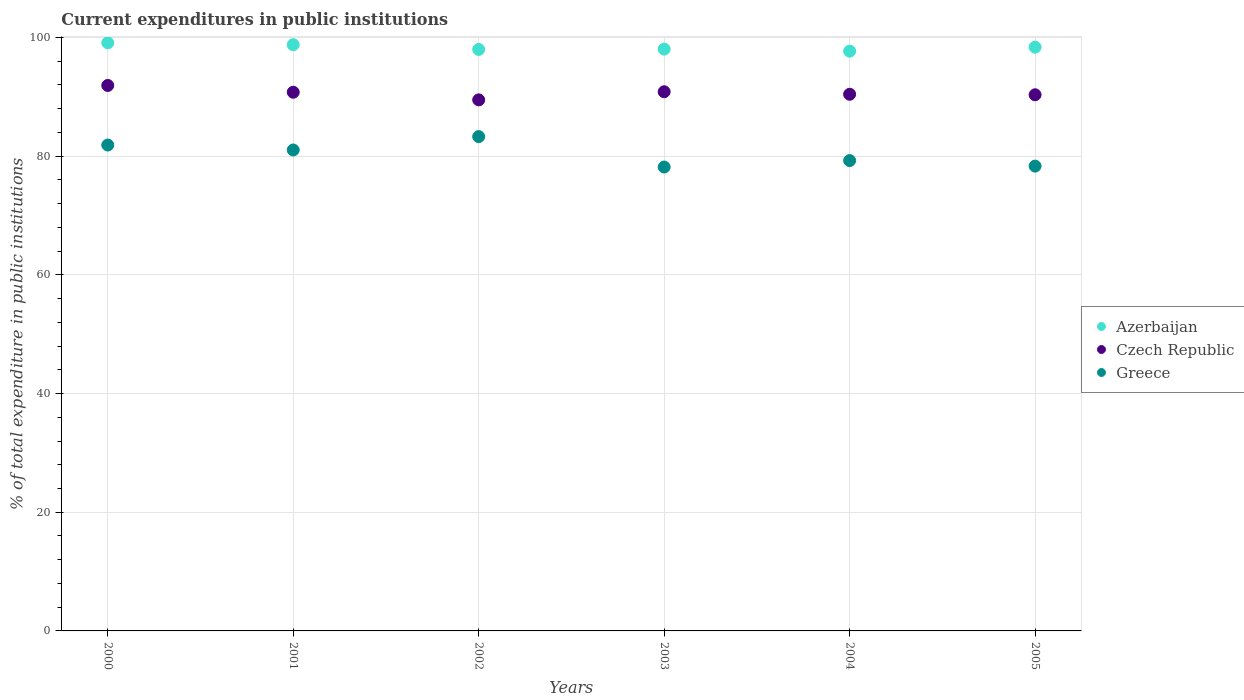What is the current expenditures in public institutions in Greece in 2004?
Your response must be concise. 79.25. Across all years, what is the maximum current expenditures in public institutions in Azerbaijan?
Give a very brief answer. 99.1. Across all years, what is the minimum current expenditures in public institutions in Czech Republic?
Ensure brevity in your answer.  89.48. In which year was the current expenditures in public institutions in Greece minimum?
Offer a very short reply. 2003. What is the total current expenditures in public institutions in Czech Republic in the graph?
Offer a very short reply. 543.78. What is the difference between the current expenditures in public institutions in Azerbaijan in 2003 and that in 2004?
Your answer should be very brief. 0.34. What is the difference between the current expenditures in public institutions in Azerbaijan in 2003 and the current expenditures in public institutions in Czech Republic in 2000?
Ensure brevity in your answer.  6.12. What is the average current expenditures in public institutions in Greece per year?
Offer a very short reply. 80.32. In the year 2000, what is the difference between the current expenditures in public institutions in Azerbaijan and current expenditures in public institutions in Greece?
Make the answer very short. 17.23. In how many years, is the current expenditures in public institutions in Azerbaijan greater than 24 %?
Your response must be concise. 6. What is the ratio of the current expenditures in public institutions in Greece in 2000 to that in 2005?
Your answer should be compact. 1.05. Is the current expenditures in public institutions in Azerbaijan in 2001 less than that in 2005?
Offer a terse response. No. Is the difference between the current expenditures in public institutions in Azerbaijan in 2000 and 2005 greater than the difference between the current expenditures in public institutions in Greece in 2000 and 2005?
Your answer should be compact. No. What is the difference between the highest and the second highest current expenditures in public institutions in Greece?
Give a very brief answer. 1.42. What is the difference between the highest and the lowest current expenditures in public institutions in Greece?
Provide a succinct answer. 5.13. Is the sum of the current expenditures in public institutions in Greece in 2002 and 2004 greater than the maximum current expenditures in public institutions in Czech Republic across all years?
Your answer should be compact. Yes. Is it the case that in every year, the sum of the current expenditures in public institutions in Azerbaijan and current expenditures in public institutions in Czech Republic  is greater than the current expenditures in public institutions in Greece?
Keep it short and to the point. Yes. Is the current expenditures in public institutions in Greece strictly less than the current expenditures in public institutions in Czech Republic over the years?
Give a very brief answer. Yes. How many dotlines are there?
Make the answer very short. 3. What is the difference between two consecutive major ticks on the Y-axis?
Keep it short and to the point. 20. Does the graph contain any zero values?
Keep it short and to the point. No. Does the graph contain grids?
Your response must be concise. Yes. How are the legend labels stacked?
Your answer should be compact. Vertical. What is the title of the graph?
Offer a very short reply. Current expenditures in public institutions. What is the label or title of the X-axis?
Provide a succinct answer. Years. What is the label or title of the Y-axis?
Your answer should be compact. % of total expenditure in public institutions. What is the % of total expenditure in public institutions in Azerbaijan in 2000?
Offer a very short reply. 99.1. What is the % of total expenditure in public institutions in Czech Republic in 2000?
Offer a terse response. 91.91. What is the % of total expenditure in public institutions in Greece in 2000?
Your answer should be very brief. 81.87. What is the % of total expenditure in public institutions of Azerbaijan in 2001?
Provide a short and direct response. 98.78. What is the % of total expenditure in public institutions of Czech Republic in 2001?
Your answer should be compact. 90.77. What is the % of total expenditure in public institutions of Greece in 2001?
Ensure brevity in your answer.  81.04. What is the % of total expenditure in public institutions in Azerbaijan in 2002?
Make the answer very short. 97.98. What is the % of total expenditure in public institutions of Czech Republic in 2002?
Ensure brevity in your answer.  89.48. What is the % of total expenditure in public institutions of Greece in 2002?
Make the answer very short. 83.29. What is the % of total expenditure in public institutions of Azerbaijan in 2003?
Your answer should be very brief. 98.03. What is the % of total expenditure in public institutions of Czech Republic in 2003?
Give a very brief answer. 90.85. What is the % of total expenditure in public institutions in Greece in 2003?
Make the answer very short. 78.16. What is the % of total expenditure in public institutions of Azerbaijan in 2004?
Ensure brevity in your answer.  97.7. What is the % of total expenditure in public institutions of Czech Republic in 2004?
Your answer should be compact. 90.43. What is the % of total expenditure in public institutions in Greece in 2004?
Offer a terse response. 79.25. What is the % of total expenditure in public institutions of Azerbaijan in 2005?
Give a very brief answer. 98.36. What is the % of total expenditure in public institutions in Czech Republic in 2005?
Your answer should be very brief. 90.34. What is the % of total expenditure in public institutions in Greece in 2005?
Provide a short and direct response. 78.32. Across all years, what is the maximum % of total expenditure in public institutions in Azerbaijan?
Your response must be concise. 99.1. Across all years, what is the maximum % of total expenditure in public institutions of Czech Republic?
Provide a succinct answer. 91.91. Across all years, what is the maximum % of total expenditure in public institutions in Greece?
Provide a succinct answer. 83.29. Across all years, what is the minimum % of total expenditure in public institutions in Azerbaijan?
Provide a short and direct response. 97.7. Across all years, what is the minimum % of total expenditure in public institutions of Czech Republic?
Give a very brief answer. 89.48. Across all years, what is the minimum % of total expenditure in public institutions of Greece?
Offer a very short reply. 78.16. What is the total % of total expenditure in public institutions in Azerbaijan in the graph?
Offer a terse response. 589.95. What is the total % of total expenditure in public institutions of Czech Republic in the graph?
Your response must be concise. 543.78. What is the total % of total expenditure in public institutions in Greece in the graph?
Make the answer very short. 481.94. What is the difference between the % of total expenditure in public institutions of Azerbaijan in 2000 and that in 2001?
Offer a terse response. 0.32. What is the difference between the % of total expenditure in public institutions of Czech Republic in 2000 and that in 2001?
Make the answer very short. 1.14. What is the difference between the % of total expenditure in public institutions of Greece in 2000 and that in 2001?
Your answer should be compact. 0.83. What is the difference between the % of total expenditure in public institutions of Azerbaijan in 2000 and that in 2002?
Make the answer very short. 1.12. What is the difference between the % of total expenditure in public institutions in Czech Republic in 2000 and that in 2002?
Your answer should be very brief. 2.43. What is the difference between the % of total expenditure in public institutions of Greece in 2000 and that in 2002?
Keep it short and to the point. -1.42. What is the difference between the % of total expenditure in public institutions in Azerbaijan in 2000 and that in 2003?
Make the answer very short. 1.07. What is the difference between the % of total expenditure in public institutions in Czech Republic in 2000 and that in 2003?
Your answer should be compact. 1.06. What is the difference between the % of total expenditure in public institutions in Greece in 2000 and that in 2003?
Provide a succinct answer. 3.71. What is the difference between the % of total expenditure in public institutions of Azerbaijan in 2000 and that in 2004?
Give a very brief answer. 1.41. What is the difference between the % of total expenditure in public institutions of Czech Republic in 2000 and that in 2004?
Keep it short and to the point. 1.49. What is the difference between the % of total expenditure in public institutions of Greece in 2000 and that in 2004?
Make the answer very short. 2.62. What is the difference between the % of total expenditure in public institutions of Azerbaijan in 2000 and that in 2005?
Provide a short and direct response. 0.74. What is the difference between the % of total expenditure in public institutions of Czech Republic in 2000 and that in 2005?
Your answer should be compact. 1.57. What is the difference between the % of total expenditure in public institutions in Greece in 2000 and that in 2005?
Ensure brevity in your answer.  3.55. What is the difference between the % of total expenditure in public institutions in Azerbaijan in 2001 and that in 2002?
Ensure brevity in your answer.  0.8. What is the difference between the % of total expenditure in public institutions of Czech Republic in 2001 and that in 2002?
Your answer should be very brief. 1.29. What is the difference between the % of total expenditure in public institutions of Greece in 2001 and that in 2002?
Provide a short and direct response. -2.25. What is the difference between the % of total expenditure in public institutions of Azerbaijan in 2001 and that in 2003?
Provide a short and direct response. 0.74. What is the difference between the % of total expenditure in public institutions in Czech Republic in 2001 and that in 2003?
Ensure brevity in your answer.  -0.08. What is the difference between the % of total expenditure in public institutions in Greece in 2001 and that in 2003?
Make the answer very short. 2.88. What is the difference between the % of total expenditure in public institutions of Azerbaijan in 2001 and that in 2004?
Provide a succinct answer. 1.08. What is the difference between the % of total expenditure in public institutions of Czech Republic in 2001 and that in 2004?
Your response must be concise. 0.34. What is the difference between the % of total expenditure in public institutions of Greece in 2001 and that in 2004?
Your answer should be very brief. 1.79. What is the difference between the % of total expenditure in public institutions of Azerbaijan in 2001 and that in 2005?
Provide a short and direct response. 0.42. What is the difference between the % of total expenditure in public institutions of Czech Republic in 2001 and that in 2005?
Give a very brief answer. 0.43. What is the difference between the % of total expenditure in public institutions in Greece in 2001 and that in 2005?
Provide a succinct answer. 2.72. What is the difference between the % of total expenditure in public institutions in Azerbaijan in 2002 and that in 2003?
Provide a short and direct response. -0.05. What is the difference between the % of total expenditure in public institutions of Czech Republic in 2002 and that in 2003?
Give a very brief answer. -1.37. What is the difference between the % of total expenditure in public institutions of Greece in 2002 and that in 2003?
Give a very brief answer. 5.13. What is the difference between the % of total expenditure in public institutions of Azerbaijan in 2002 and that in 2004?
Give a very brief answer. 0.29. What is the difference between the % of total expenditure in public institutions of Czech Republic in 2002 and that in 2004?
Offer a very short reply. -0.94. What is the difference between the % of total expenditure in public institutions of Greece in 2002 and that in 2004?
Offer a very short reply. 4.04. What is the difference between the % of total expenditure in public institutions of Azerbaijan in 2002 and that in 2005?
Ensure brevity in your answer.  -0.38. What is the difference between the % of total expenditure in public institutions in Czech Republic in 2002 and that in 2005?
Your answer should be very brief. -0.86. What is the difference between the % of total expenditure in public institutions of Greece in 2002 and that in 2005?
Offer a very short reply. 4.97. What is the difference between the % of total expenditure in public institutions in Azerbaijan in 2003 and that in 2004?
Your response must be concise. 0.34. What is the difference between the % of total expenditure in public institutions in Czech Republic in 2003 and that in 2004?
Your answer should be compact. 0.42. What is the difference between the % of total expenditure in public institutions of Greece in 2003 and that in 2004?
Ensure brevity in your answer.  -1.09. What is the difference between the % of total expenditure in public institutions of Azerbaijan in 2003 and that in 2005?
Keep it short and to the point. -0.33. What is the difference between the % of total expenditure in public institutions in Czech Republic in 2003 and that in 2005?
Make the answer very short. 0.51. What is the difference between the % of total expenditure in public institutions of Greece in 2003 and that in 2005?
Ensure brevity in your answer.  -0.16. What is the difference between the % of total expenditure in public institutions in Azerbaijan in 2004 and that in 2005?
Make the answer very short. -0.66. What is the difference between the % of total expenditure in public institutions of Czech Republic in 2004 and that in 2005?
Keep it short and to the point. 0.09. What is the difference between the % of total expenditure in public institutions in Greece in 2004 and that in 2005?
Give a very brief answer. 0.93. What is the difference between the % of total expenditure in public institutions in Azerbaijan in 2000 and the % of total expenditure in public institutions in Czech Republic in 2001?
Provide a short and direct response. 8.33. What is the difference between the % of total expenditure in public institutions of Azerbaijan in 2000 and the % of total expenditure in public institutions of Greece in 2001?
Make the answer very short. 18.06. What is the difference between the % of total expenditure in public institutions in Czech Republic in 2000 and the % of total expenditure in public institutions in Greece in 2001?
Keep it short and to the point. 10.87. What is the difference between the % of total expenditure in public institutions in Azerbaijan in 2000 and the % of total expenditure in public institutions in Czech Republic in 2002?
Give a very brief answer. 9.62. What is the difference between the % of total expenditure in public institutions in Azerbaijan in 2000 and the % of total expenditure in public institutions in Greece in 2002?
Give a very brief answer. 15.81. What is the difference between the % of total expenditure in public institutions in Czech Republic in 2000 and the % of total expenditure in public institutions in Greece in 2002?
Your response must be concise. 8.62. What is the difference between the % of total expenditure in public institutions of Azerbaijan in 2000 and the % of total expenditure in public institutions of Czech Republic in 2003?
Make the answer very short. 8.25. What is the difference between the % of total expenditure in public institutions of Azerbaijan in 2000 and the % of total expenditure in public institutions of Greece in 2003?
Ensure brevity in your answer.  20.94. What is the difference between the % of total expenditure in public institutions of Czech Republic in 2000 and the % of total expenditure in public institutions of Greece in 2003?
Ensure brevity in your answer.  13.75. What is the difference between the % of total expenditure in public institutions in Azerbaijan in 2000 and the % of total expenditure in public institutions in Czech Republic in 2004?
Ensure brevity in your answer.  8.67. What is the difference between the % of total expenditure in public institutions of Azerbaijan in 2000 and the % of total expenditure in public institutions of Greece in 2004?
Offer a terse response. 19.85. What is the difference between the % of total expenditure in public institutions in Czech Republic in 2000 and the % of total expenditure in public institutions in Greece in 2004?
Provide a short and direct response. 12.66. What is the difference between the % of total expenditure in public institutions of Azerbaijan in 2000 and the % of total expenditure in public institutions of Czech Republic in 2005?
Give a very brief answer. 8.76. What is the difference between the % of total expenditure in public institutions in Azerbaijan in 2000 and the % of total expenditure in public institutions in Greece in 2005?
Ensure brevity in your answer.  20.78. What is the difference between the % of total expenditure in public institutions of Czech Republic in 2000 and the % of total expenditure in public institutions of Greece in 2005?
Offer a very short reply. 13.59. What is the difference between the % of total expenditure in public institutions of Azerbaijan in 2001 and the % of total expenditure in public institutions of Czech Republic in 2002?
Make the answer very short. 9.29. What is the difference between the % of total expenditure in public institutions in Azerbaijan in 2001 and the % of total expenditure in public institutions in Greece in 2002?
Provide a succinct answer. 15.49. What is the difference between the % of total expenditure in public institutions in Czech Republic in 2001 and the % of total expenditure in public institutions in Greece in 2002?
Provide a succinct answer. 7.48. What is the difference between the % of total expenditure in public institutions of Azerbaijan in 2001 and the % of total expenditure in public institutions of Czech Republic in 2003?
Make the answer very short. 7.93. What is the difference between the % of total expenditure in public institutions in Azerbaijan in 2001 and the % of total expenditure in public institutions in Greece in 2003?
Your answer should be very brief. 20.61. What is the difference between the % of total expenditure in public institutions in Czech Republic in 2001 and the % of total expenditure in public institutions in Greece in 2003?
Ensure brevity in your answer.  12.6. What is the difference between the % of total expenditure in public institutions in Azerbaijan in 2001 and the % of total expenditure in public institutions in Czech Republic in 2004?
Keep it short and to the point. 8.35. What is the difference between the % of total expenditure in public institutions of Azerbaijan in 2001 and the % of total expenditure in public institutions of Greece in 2004?
Offer a very short reply. 19.53. What is the difference between the % of total expenditure in public institutions of Czech Republic in 2001 and the % of total expenditure in public institutions of Greece in 2004?
Provide a short and direct response. 11.52. What is the difference between the % of total expenditure in public institutions of Azerbaijan in 2001 and the % of total expenditure in public institutions of Czech Republic in 2005?
Ensure brevity in your answer.  8.44. What is the difference between the % of total expenditure in public institutions in Azerbaijan in 2001 and the % of total expenditure in public institutions in Greece in 2005?
Provide a short and direct response. 20.46. What is the difference between the % of total expenditure in public institutions of Czech Republic in 2001 and the % of total expenditure in public institutions of Greece in 2005?
Provide a succinct answer. 12.45. What is the difference between the % of total expenditure in public institutions in Azerbaijan in 2002 and the % of total expenditure in public institutions in Czech Republic in 2003?
Offer a very short reply. 7.13. What is the difference between the % of total expenditure in public institutions of Azerbaijan in 2002 and the % of total expenditure in public institutions of Greece in 2003?
Your answer should be very brief. 19.82. What is the difference between the % of total expenditure in public institutions of Czech Republic in 2002 and the % of total expenditure in public institutions of Greece in 2003?
Keep it short and to the point. 11.32. What is the difference between the % of total expenditure in public institutions in Azerbaijan in 2002 and the % of total expenditure in public institutions in Czech Republic in 2004?
Provide a short and direct response. 7.56. What is the difference between the % of total expenditure in public institutions in Azerbaijan in 2002 and the % of total expenditure in public institutions in Greece in 2004?
Offer a very short reply. 18.73. What is the difference between the % of total expenditure in public institutions in Czech Republic in 2002 and the % of total expenditure in public institutions in Greece in 2004?
Your answer should be compact. 10.23. What is the difference between the % of total expenditure in public institutions of Azerbaijan in 2002 and the % of total expenditure in public institutions of Czech Republic in 2005?
Your response must be concise. 7.64. What is the difference between the % of total expenditure in public institutions of Azerbaijan in 2002 and the % of total expenditure in public institutions of Greece in 2005?
Your answer should be very brief. 19.66. What is the difference between the % of total expenditure in public institutions of Czech Republic in 2002 and the % of total expenditure in public institutions of Greece in 2005?
Make the answer very short. 11.16. What is the difference between the % of total expenditure in public institutions of Azerbaijan in 2003 and the % of total expenditure in public institutions of Czech Republic in 2004?
Offer a terse response. 7.61. What is the difference between the % of total expenditure in public institutions of Azerbaijan in 2003 and the % of total expenditure in public institutions of Greece in 2004?
Your answer should be compact. 18.78. What is the difference between the % of total expenditure in public institutions in Czech Republic in 2003 and the % of total expenditure in public institutions in Greece in 2004?
Your answer should be very brief. 11.6. What is the difference between the % of total expenditure in public institutions in Azerbaijan in 2003 and the % of total expenditure in public institutions in Czech Republic in 2005?
Offer a terse response. 7.69. What is the difference between the % of total expenditure in public institutions of Azerbaijan in 2003 and the % of total expenditure in public institutions of Greece in 2005?
Make the answer very short. 19.71. What is the difference between the % of total expenditure in public institutions in Czech Republic in 2003 and the % of total expenditure in public institutions in Greece in 2005?
Keep it short and to the point. 12.53. What is the difference between the % of total expenditure in public institutions in Azerbaijan in 2004 and the % of total expenditure in public institutions in Czech Republic in 2005?
Ensure brevity in your answer.  7.35. What is the difference between the % of total expenditure in public institutions in Azerbaijan in 2004 and the % of total expenditure in public institutions in Greece in 2005?
Provide a short and direct response. 19.37. What is the difference between the % of total expenditure in public institutions in Czech Republic in 2004 and the % of total expenditure in public institutions in Greece in 2005?
Your answer should be very brief. 12.1. What is the average % of total expenditure in public institutions in Azerbaijan per year?
Ensure brevity in your answer.  98.32. What is the average % of total expenditure in public institutions of Czech Republic per year?
Your answer should be compact. 90.63. What is the average % of total expenditure in public institutions in Greece per year?
Provide a succinct answer. 80.32. In the year 2000, what is the difference between the % of total expenditure in public institutions of Azerbaijan and % of total expenditure in public institutions of Czech Republic?
Provide a succinct answer. 7.19. In the year 2000, what is the difference between the % of total expenditure in public institutions of Azerbaijan and % of total expenditure in public institutions of Greece?
Ensure brevity in your answer.  17.23. In the year 2000, what is the difference between the % of total expenditure in public institutions in Czech Republic and % of total expenditure in public institutions in Greece?
Your response must be concise. 10.04. In the year 2001, what is the difference between the % of total expenditure in public institutions in Azerbaijan and % of total expenditure in public institutions in Czech Republic?
Offer a terse response. 8.01. In the year 2001, what is the difference between the % of total expenditure in public institutions of Azerbaijan and % of total expenditure in public institutions of Greece?
Offer a terse response. 17.74. In the year 2001, what is the difference between the % of total expenditure in public institutions of Czech Republic and % of total expenditure in public institutions of Greece?
Provide a succinct answer. 9.73. In the year 2002, what is the difference between the % of total expenditure in public institutions in Azerbaijan and % of total expenditure in public institutions in Czech Republic?
Keep it short and to the point. 8.5. In the year 2002, what is the difference between the % of total expenditure in public institutions of Azerbaijan and % of total expenditure in public institutions of Greece?
Your response must be concise. 14.69. In the year 2002, what is the difference between the % of total expenditure in public institutions of Czech Republic and % of total expenditure in public institutions of Greece?
Offer a very short reply. 6.19. In the year 2003, what is the difference between the % of total expenditure in public institutions in Azerbaijan and % of total expenditure in public institutions in Czech Republic?
Keep it short and to the point. 7.18. In the year 2003, what is the difference between the % of total expenditure in public institutions in Azerbaijan and % of total expenditure in public institutions in Greece?
Your answer should be very brief. 19.87. In the year 2003, what is the difference between the % of total expenditure in public institutions in Czech Republic and % of total expenditure in public institutions in Greece?
Provide a short and direct response. 12.68. In the year 2004, what is the difference between the % of total expenditure in public institutions in Azerbaijan and % of total expenditure in public institutions in Czech Republic?
Ensure brevity in your answer.  7.27. In the year 2004, what is the difference between the % of total expenditure in public institutions of Azerbaijan and % of total expenditure in public institutions of Greece?
Provide a short and direct response. 18.44. In the year 2004, what is the difference between the % of total expenditure in public institutions in Czech Republic and % of total expenditure in public institutions in Greece?
Offer a very short reply. 11.17. In the year 2005, what is the difference between the % of total expenditure in public institutions of Azerbaijan and % of total expenditure in public institutions of Czech Republic?
Your answer should be very brief. 8.02. In the year 2005, what is the difference between the % of total expenditure in public institutions of Azerbaijan and % of total expenditure in public institutions of Greece?
Offer a very short reply. 20.04. In the year 2005, what is the difference between the % of total expenditure in public institutions in Czech Republic and % of total expenditure in public institutions in Greece?
Give a very brief answer. 12.02. What is the ratio of the % of total expenditure in public institutions in Czech Republic in 2000 to that in 2001?
Provide a succinct answer. 1.01. What is the ratio of the % of total expenditure in public institutions of Greece in 2000 to that in 2001?
Ensure brevity in your answer.  1.01. What is the ratio of the % of total expenditure in public institutions of Azerbaijan in 2000 to that in 2002?
Your answer should be very brief. 1.01. What is the ratio of the % of total expenditure in public institutions of Czech Republic in 2000 to that in 2002?
Ensure brevity in your answer.  1.03. What is the ratio of the % of total expenditure in public institutions of Azerbaijan in 2000 to that in 2003?
Make the answer very short. 1.01. What is the ratio of the % of total expenditure in public institutions of Czech Republic in 2000 to that in 2003?
Provide a succinct answer. 1.01. What is the ratio of the % of total expenditure in public institutions in Greece in 2000 to that in 2003?
Your answer should be compact. 1.05. What is the ratio of the % of total expenditure in public institutions in Azerbaijan in 2000 to that in 2004?
Provide a short and direct response. 1.01. What is the ratio of the % of total expenditure in public institutions of Czech Republic in 2000 to that in 2004?
Offer a very short reply. 1.02. What is the ratio of the % of total expenditure in public institutions of Greece in 2000 to that in 2004?
Offer a very short reply. 1.03. What is the ratio of the % of total expenditure in public institutions of Azerbaijan in 2000 to that in 2005?
Ensure brevity in your answer.  1.01. What is the ratio of the % of total expenditure in public institutions in Czech Republic in 2000 to that in 2005?
Your response must be concise. 1.02. What is the ratio of the % of total expenditure in public institutions in Greece in 2000 to that in 2005?
Provide a succinct answer. 1.05. What is the ratio of the % of total expenditure in public institutions in Azerbaijan in 2001 to that in 2002?
Your answer should be compact. 1.01. What is the ratio of the % of total expenditure in public institutions of Czech Republic in 2001 to that in 2002?
Provide a short and direct response. 1.01. What is the ratio of the % of total expenditure in public institutions in Azerbaijan in 2001 to that in 2003?
Make the answer very short. 1.01. What is the ratio of the % of total expenditure in public institutions in Greece in 2001 to that in 2003?
Your response must be concise. 1.04. What is the ratio of the % of total expenditure in public institutions of Azerbaijan in 2001 to that in 2004?
Provide a short and direct response. 1.01. What is the ratio of the % of total expenditure in public institutions of Czech Republic in 2001 to that in 2004?
Give a very brief answer. 1. What is the ratio of the % of total expenditure in public institutions of Greece in 2001 to that in 2004?
Offer a very short reply. 1.02. What is the ratio of the % of total expenditure in public institutions of Czech Republic in 2001 to that in 2005?
Your answer should be compact. 1. What is the ratio of the % of total expenditure in public institutions in Greece in 2001 to that in 2005?
Ensure brevity in your answer.  1.03. What is the ratio of the % of total expenditure in public institutions in Czech Republic in 2002 to that in 2003?
Your response must be concise. 0.98. What is the ratio of the % of total expenditure in public institutions of Greece in 2002 to that in 2003?
Ensure brevity in your answer.  1.07. What is the ratio of the % of total expenditure in public institutions in Czech Republic in 2002 to that in 2004?
Make the answer very short. 0.99. What is the ratio of the % of total expenditure in public institutions in Greece in 2002 to that in 2004?
Give a very brief answer. 1.05. What is the ratio of the % of total expenditure in public institutions in Greece in 2002 to that in 2005?
Offer a terse response. 1.06. What is the ratio of the % of total expenditure in public institutions of Azerbaijan in 2003 to that in 2004?
Your answer should be compact. 1. What is the ratio of the % of total expenditure in public institutions in Czech Republic in 2003 to that in 2004?
Keep it short and to the point. 1. What is the ratio of the % of total expenditure in public institutions in Greece in 2003 to that in 2004?
Provide a short and direct response. 0.99. What is the ratio of the % of total expenditure in public institutions of Azerbaijan in 2003 to that in 2005?
Offer a very short reply. 1. What is the ratio of the % of total expenditure in public institutions in Czech Republic in 2003 to that in 2005?
Provide a short and direct response. 1.01. What is the ratio of the % of total expenditure in public institutions of Greece in 2003 to that in 2005?
Provide a short and direct response. 1. What is the ratio of the % of total expenditure in public institutions in Azerbaijan in 2004 to that in 2005?
Provide a short and direct response. 0.99. What is the ratio of the % of total expenditure in public institutions of Czech Republic in 2004 to that in 2005?
Your answer should be very brief. 1. What is the ratio of the % of total expenditure in public institutions in Greece in 2004 to that in 2005?
Provide a succinct answer. 1.01. What is the difference between the highest and the second highest % of total expenditure in public institutions in Azerbaijan?
Give a very brief answer. 0.32. What is the difference between the highest and the second highest % of total expenditure in public institutions in Czech Republic?
Ensure brevity in your answer.  1.06. What is the difference between the highest and the second highest % of total expenditure in public institutions of Greece?
Offer a terse response. 1.42. What is the difference between the highest and the lowest % of total expenditure in public institutions in Azerbaijan?
Give a very brief answer. 1.41. What is the difference between the highest and the lowest % of total expenditure in public institutions of Czech Republic?
Your answer should be compact. 2.43. What is the difference between the highest and the lowest % of total expenditure in public institutions of Greece?
Provide a short and direct response. 5.13. 